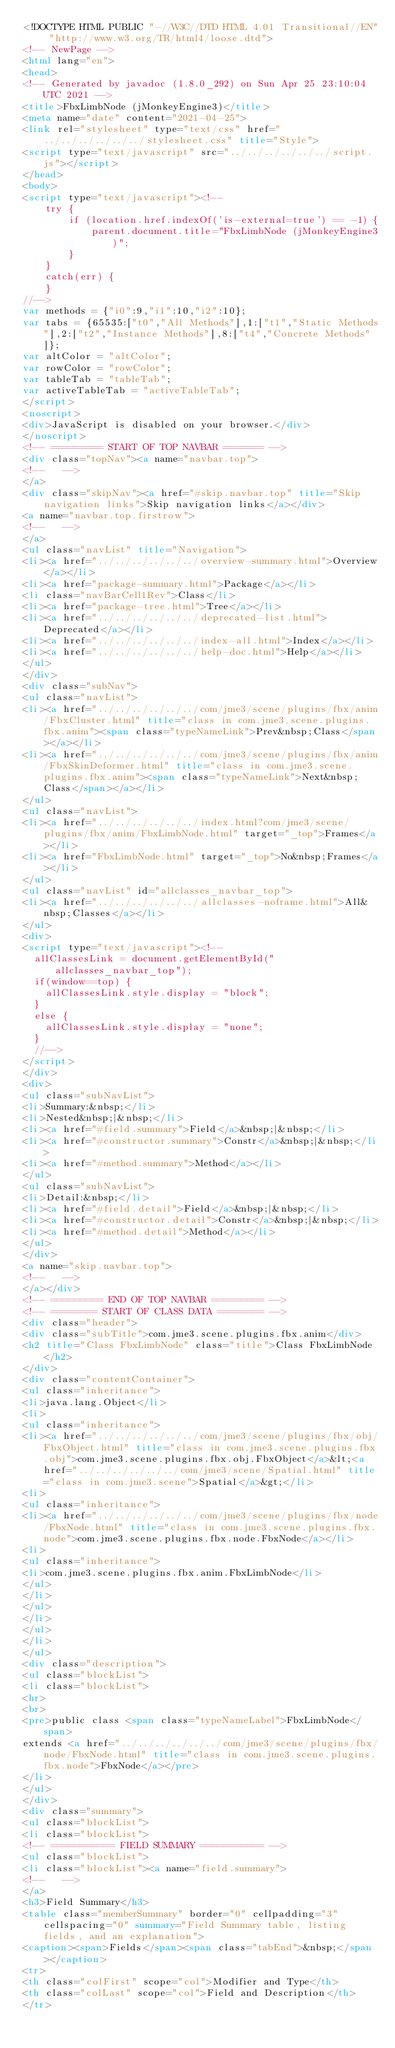Convert code to text. <code><loc_0><loc_0><loc_500><loc_500><_HTML_><!DOCTYPE HTML PUBLIC "-//W3C//DTD HTML 4.01 Transitional//EN" "http://www.w3.org/TR/html4/loose.dtd">
<!-- NewPage -->
<html lang="en">
<head>
<!-- Generated by javadoc (1.8.0_292) on Sun Apr 25 23:10:04 UTC 2021 -->
<title>FbxLimbNode (jMonkeyEngine3)</title>
<meta name="date" content="2021-04-25">
<link rel="stylesheet" type="text/css" href="../../../../../../stylesheet.css" title="Style">
<script type="text/javascript" src="../../../../../../script.js"></script>
</head>
<body>
<script type="text/javascript"><!--
    try {
        if (location.href.indexOf('is-external=true') == -1) {
            parent.document.title="FbxLimbNode (jMonkeyEngine3)";
        }
    }
    catch(err) {
    }
//-->
var methods = {"i0":9,"i1":10,"i2":10};
var tabs = {65535:["t0","All Methods"],1:["t1","Static Methods"],2:["t2","Instance Methods"],8:["t4","Concrete Methods"]};
var altColor = "altColor";
var rowColor = "rowColor";
var tableTab = "tableTab";
var activeTableTab = "activeTableTab";
</script>
<noscript>
<div>JavaScript is disabled on your browser.</div>
</noscript>
<!-- ========= START OF TOP NAVBAR ======= -->
<div class="topNav"><a name="navbar.top">
<!--   -->
</a>
<div class="skipNav"><a href="#skip.navbar.top" title="Skip navigation links">Skip navigation links</a></div>
<a name="navbar.top.firstrow">
<!--   -->
</a>
<ul class="navList" title="Navigation">
<li><a href="../../../../../../overview-summary.html">Overview</a></li>
<li><a href="package-summary.html">Package</a></li>
<li class="navBarCell1Rev">Class</li>
<li><a href="package-tree.html">Tree</a></li>
<li><a href="../../../../../../deprecated-list.html">Deprecated</a></li>
<li><a href="../../../../../../index-all.html">Index</a></li>
<li><a href="../../../../../../help-doc.html">Help</a></li>
</ul>
</div>
<div class="subNav">
<ul class="navList">
<li><a href="../../../../../../com/jme3/scene/plugins/fbx/anim/FbxCluster.html" title="class in com.jme3.scene.plugins.fbx.anim"><span class="typeNameLink">Prev&nbsp;Class</span></a></li>
<li><a href="../../../../../../com/jme3/scene/plugins/fbx/anim/FbxSkinDeformer.html" title="class in com.jme3.scene.plugins.fbx.anim"><span class="typeNameLink">Next&nbsp;Class</span></a></li>
</ul>
<ul class="navList">
<li><a href="../../../../../../index.html?com/jme3/scene/plugins/fbx/anim/FbxLimbNode.html" target="_top">Frames</a></li>
<li><a href="FbxLimbNode.html" target="_top">No&nbsp;Frames</a></li>
</ul>
<ul class="navList" id="allclasses_navbar_top">
<li><a href="../../../../../../allclasses-noframe.html">All&nbsp;Classes</a></li>
</ul>
<div>
<script type="text/javascript"><!--
  allClassesLink = document.getElementById("allclasses_navbar_top");
  if(window==top) {
    allClassesLink.style.display = "block";
  }
  else {
    allClassesLink.style.display = "none";
  }
  //-->
</script>
</div>
<div>
<ul class="subNavList">
<li>Summary:&nbsp;</li>
<li>Nested&nbsp;|&nbsp;</li>
<li><a href="#field.summary">Field</a>&nbsp;|&nbsp;</li>
<li><a href="#constructor.summary">Constr</a>&nbsp;|&nbsp;</li>
<li><a href="#method.summary">Method</a></li>
</ul>
<ul class="subNavList">
<li>Detail:&nbsp;</li>
<li><a href="#field.detail">Field</a>&nbsp;|&nbsp;</li>
<li><a href="#constructor.detail">Constr</a>&nbsp;|&nbsp;</li>
<li><a href="#method.detail">Method</a></li>
</ul>
</div>
<a name="skip.navbar.top">
<!--   -->
</a></div>
<!-- ========= END OF TOP NAVBAR ========= -->
<!-- ======== START OF CLASS DATA ======== -->
<div class="header">
<div class="subTitle">com.jme3.scene.plugins.fbx.anim</div>
<h2 title="Class FbxLimbNode" class="title">Class FbxLimbNode</h2>
</div>
<div class="contentContainer">
<ul class="inheritance">
<li>java.lang.Object</li>
<li>
<ul class="inheritance">
<li><a href="../../../../../../com/jme3/scene/plugins/fbx/obj/FbxObject.html" title="class in com.jme3.scene.plugins.fbx.obj">com.jme3.scene.plugins.fbx.obj.FbxObject</a>&lt;<a href="../../../../../../com/jme3/scene/Spatial.html" title="class in com.jme3.scene">Spatial</a>&gt;</li>
<li>
<ul class="inheritance">
<li><a href="../../../../../../com/jme3/scene/plugins/fbx/node/FbxNode.html" title="class in com.jme3.scene.plugins.fbx.node">com.jme3.scene.plugins.fbx.node.FbxNode</a></li>
<li>
<ul class="inheritance">
<li>com.jme3.scene.plugins.fbx.anim.FbxLimbNode</li>
</ul>
</li>
</ul>
</li>
</ul>
</li>
</ul>
<div class="description">
<ul class="blockList">
<li class="blockList">
<hr>
<br>
<pre>public class <span class="typeNameLabel">FbxLimbNode</span>
extends <a href="../../../../../../com/jme3/scene/plugins/fbx/node/FbxNode.html" title="class in com.jme3.scene.plugins.fbx.node">FbxNode</a></pre>
</li>
</ul>
</div>
<div class="summary">
<ul class="blockList">
<li class="blockList">
<!-- =========== FIELD SUMMARY =========== -->
<ul class="blockList">
<li class="blockList"><a name="field.summary">
<!--   -->
</a>
<h3>Field Summary</h3>
<table class="memberSummary" border="0" cellpadding="3" cellspacing="0" summary="Field Summary table, listing fields, and an explanation">
<caption><span>Fields</span><span class="tabEnd">&nbsp;</span></caption>
<tr>
<th class="colFirst" scope="col">Modifier and Type</th>
<th class="colLast" scope="col">Field and Description</th>
</tr></code> 